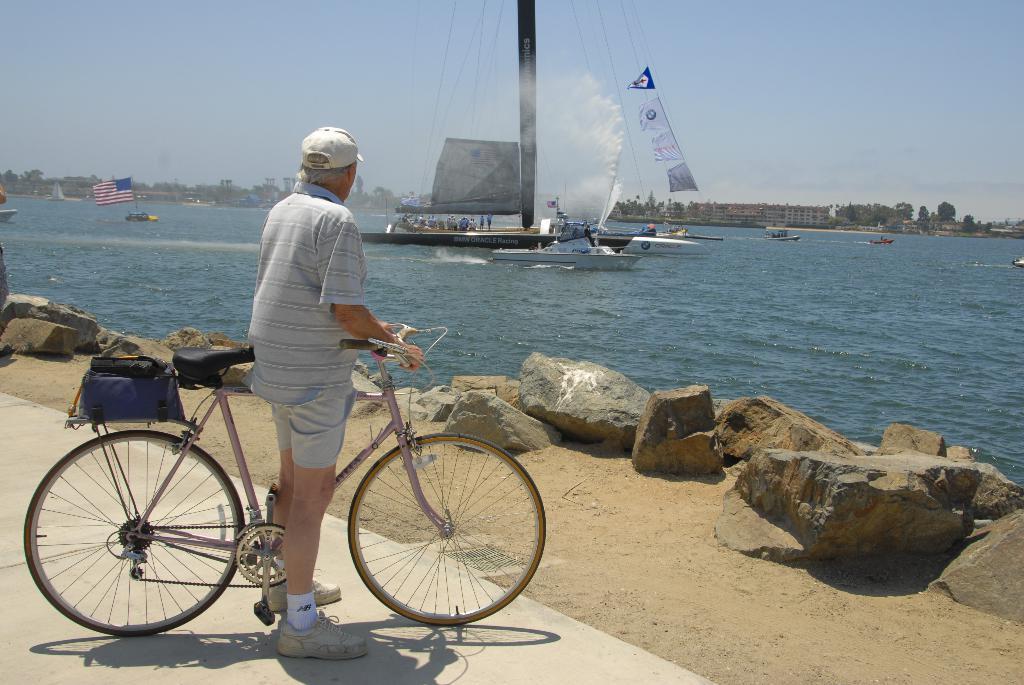How would you summarize this image in a sentence or two? In this picture we can see a old man holding a bicycle who is wearing a short and shirt and in front of him there are some stones and a sea in which there is a boat. 